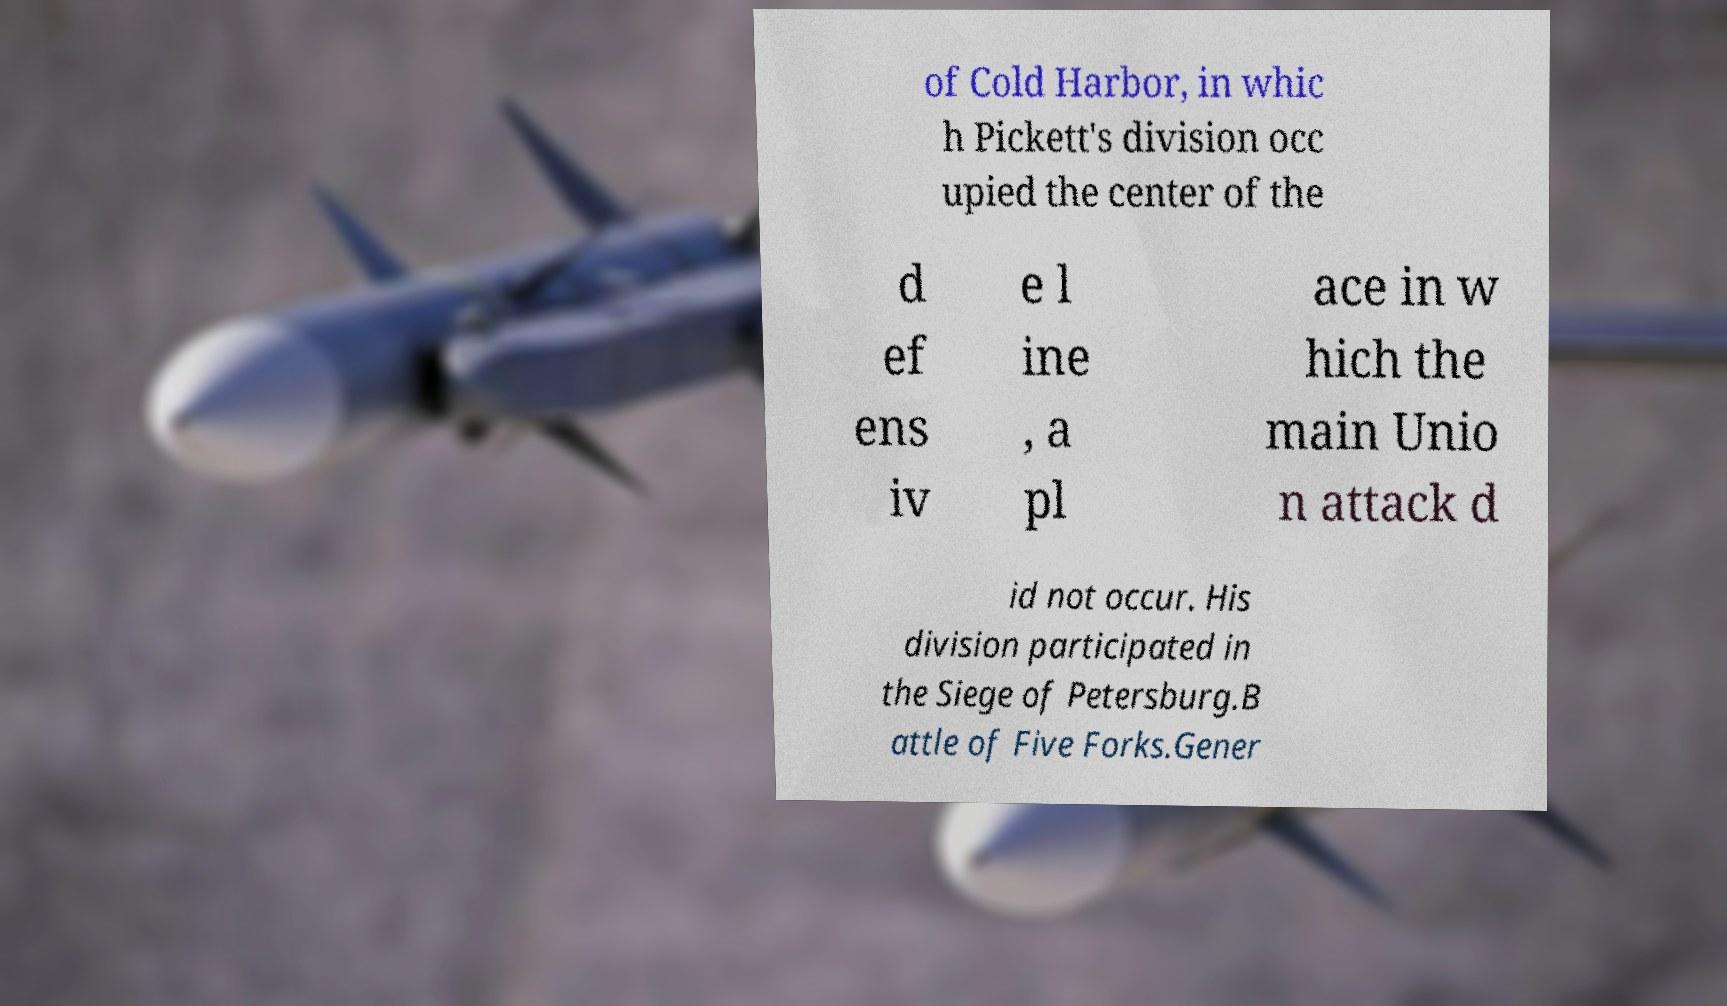Could you extract and type out the text from this image? of Cold Harbor, in whic h Pickett's division occ upied the center of the d ef ens iv e l ine , a pl ace in w hich the main Unio n attack d id not occur. His division participated in the Siege of Petersburg.B attle of Five Forks.Gener 